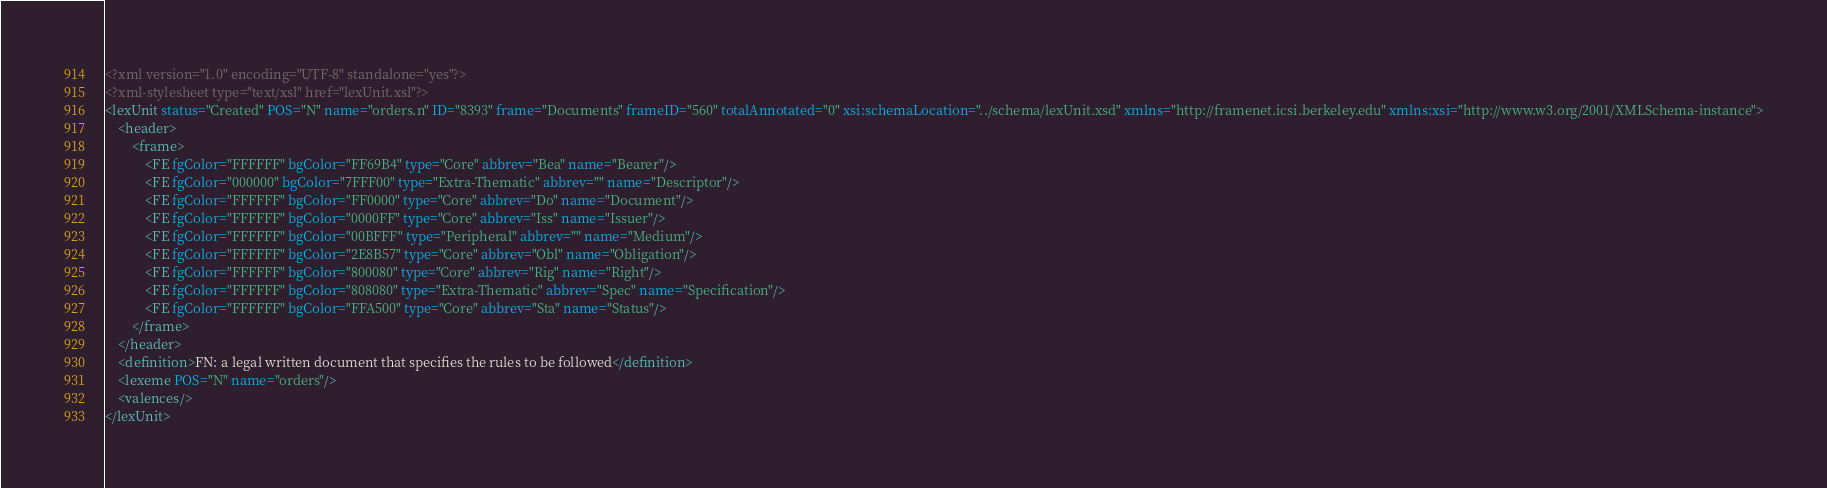Convert code to text. <code><loc_0><loc_0><loc_500><loc_500><_XML_><?xml version="1.0" encoding="UTF-8" standalone="yes"?>
<?xml-stylesheet type="text/xsl" href="lexUnit.xsl"?>
<lexUnit status="Created" POS="N" name="orders.n" ID="8393" frame="Documents" frameID="560" totalAnnotated="0" xsi:schemaLocation="../schema/lexUnit.xsd" xmlns="http://framenet.icsi.berkeley.edu" xmlns:xsi="http://www.w3.org/2001/XMLSchema-instance">
    <header>
        <frame>
            <FE fgColor="FFFFFF" bgColor="FF69B4" type="Core" abbrev="Bea" name="Bearer"/>
            <FE fgColor="000000" bgColor="7FFF00" type="Extra-Thematic" abbrev="" name="Descriptor"/>
            <FE fgColor="FFFFFF" bgColor="FF0000" type="Core" abbrev="Do" name="Document"/>
            <FE fgColor="FFFFFF" bgColor="0000FF" type="Core" abbrev="Iss" name="Issuer"/>
            <FE fgColor="FFFFFF" bgColor="00BFFF" type="Peripheral" abbrev="" name="Medium"/>
            <FE fgColor="FFFFFF" bgColor="2E8B57" type="Core" abbrev="Obl" name="Obligation"/>
            <FE fgColor="FFFFFF" bgColor="800080" type="Core" abbrev="Rig" name="Right"/>
            <FE fgColor="FFFFFF" bgColor="808080" type="Extra-Thematic" abbrev="Spec" name="Specification"/>
            <FE fgColor="FFFFFF" bgColor="FFA500" type="Core" abbrev="Sta" name="Status"/>
        </frame>
    </header>
    <definition>FN: a legal written document that specifies the rules to be followed</definition>
    <lexeme POS="N" name="orders"/>
    <valences/>
</lexUnit></code> 